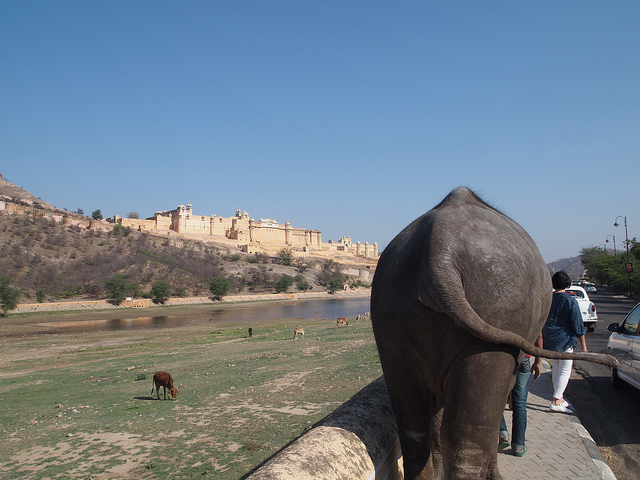<image>Is this picture in the northern hemisphere? It is ambiguous if the picture is in the northern hemisphere. Is this picture in the northern hemisphere? I don't know if this picture is in the northern hemisphere. It can be both in the northern hemisphere and other hemispheres. 